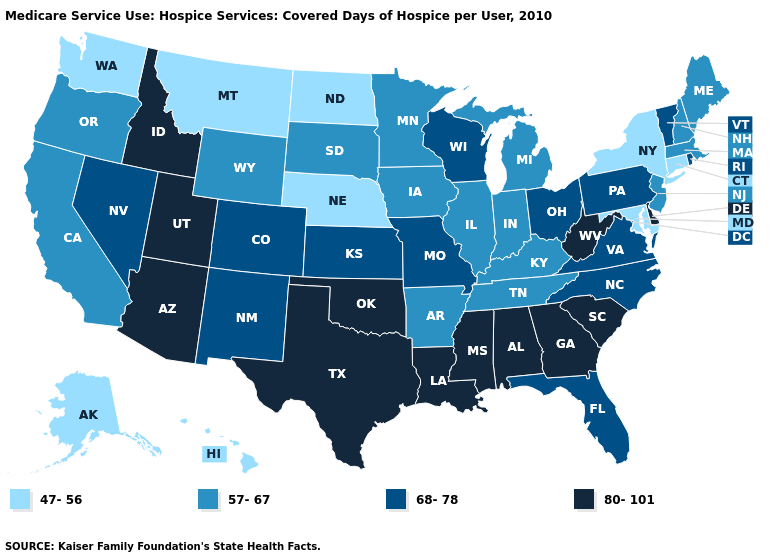Among the states that border Oregon , does Washington have the highest value?
Quick response, please. No. Does Alaska have the lowest value in the West?
Write a very short answer. Yes. Does the first symbol in the legend represent the smallest category?
Write a very short answer. Yes. Which states have the highest value in the USA?
Concise answer only. Alabama, Arizona, Delaware, Georgia, Idaho, Louisiana, Mississippi, Oklahoma, South Carolina, Texas, Utah, West Virginia. Does Nebraska have the lowest value in the MidWest?
Short answer required. Yes. Name the states that have a value in the range 80-101?
Concise answer only. Alabama, Arizona, Delaware, Georgia, Idaho, Louisiana, Mississippi, Oklahoma, South Carolina, Texas, Utah, West Virginia. What is the lowest value in the Northeast?
Keep it brief. 47-56. Among the states that border Washington , does Oregon have the lowest value?
Give a very brief answer. Yes. What is the value of Kansas?
Be succinct. 68-78. Which states have the highest value in the USA?
Be succinct. Alabama, Arizona, Delaware, Georgia, Idaho, Louisiana, Mississippi, Oklahoma, South Carolina, Texas, Utah, West Virginia. What is the lowest value in the USA?
Write a very short answer. 47-56. What is the value of Nebraska?
Concise answer only. 47-56. Name the states that have a value in the range 80-101?
Quick response, please. Alabama, Arizona, Delaware, Georgia, Idaho, Louisiana, Mississippi, Oklahoma, South Carolina, Texas, Utah, West Virginia. Does the first symbol in the legend represent the smallest category?
Be succinct. Yes. Does North Dakota have a lower value than Minnesota?
Be succinct. Yes. 